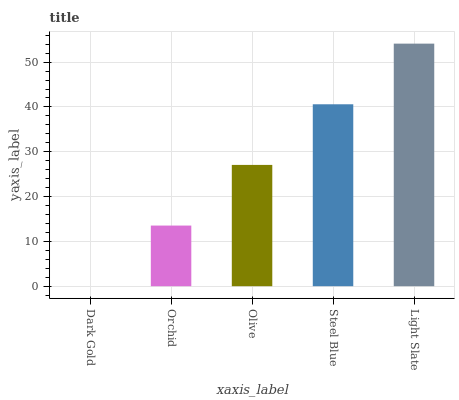Is Dark Gold the minimum?
Answer yes or no. Yes. Is Light Slate the maximum?
Answer yes or no. Yes. Is Orchid the minimum?
Answer yes or no. No. Is Orchid the maximum?
Answer yes or no. No. Is Orchid greater than Dark Gold?
Answer yes or no. Yes. Is Dark Gold less than Orchid?
Answer yes or no. Yes. Is Dark Gold greater than Orchid?
Answer yes or no. No. Is Orchid less than Dark Gold?
Answer yes or no. No. Is Olive the high median?
Answer yes or no. Yes. Is Olive the low median?
Answer yes or no. Yes. Is Orchid the high median?
Answer yes or no. No. Is Light Slate the low median?
Answer yes or no. No. 